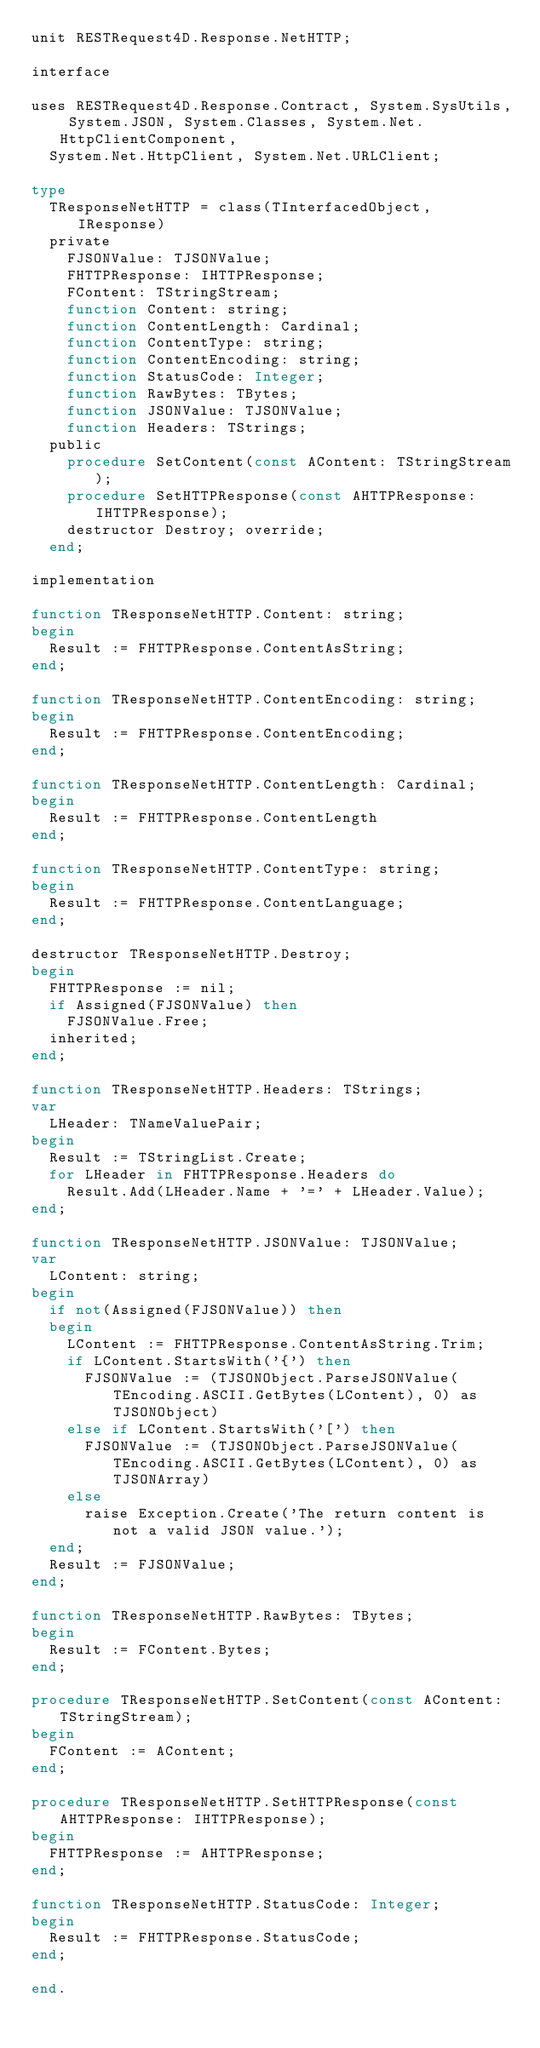Convert code to text. <code><loc_0><loc_0><loc_500><loc_500><_Pascal_>unit RESTRequest4D.Response.NetHTTP;

interface

uses RESTRequest4D.Response.Contract, System.SysUtils, System.JSON, System.Classes, System.Net.HttpClientComponent,
  System.Net.HttpClient, System.Net.URLClient;

type
  TResponseNetHTTP = class(TInterfacedObject, IResponse)
  private
    FJSONValue: TJSONValue;
    FHTTPResponse: IHTTPResponse;
    FContent: TStringStream;
    function Content: string;
    function ContentLength: Cardinal;
    function ContentType: string;
    function ContentEncoding: string;
    function StatusCode: Integer;
    function RawBytes: TBytes;
    function JSONValue: TJSONValue;
    function Headers: TStrings;
  public
    procedure SetContent(const AContent: TStringStream);
    procedure SetHTTPResponse(const AHTTPResponse: IHTTPResponse);
    destructor Destroy; override;
  end;

implementation

function TResponseNetHTTP.Content: string;
begin
  Result := FHTTPResponse.ContentAsString;
end;

function TResponseNetHTTP.ContentEncoding: string;
begin
  Result := FHTTPResponse.ContentEncoding;
end;

function TResponseNetHTTP.ContentLength: Cardinal;
begin
  Result := FHTTPResponse.ContentLength
end;

function TResponseNetHTTP.ContentType: string;
begin
  Result := FHTTPResponse.ContentLanguage;
end;

destructor TResponseNetHTTP.Destroy;
begin
  FHTTPResponse := nil;
  if Assigned(FJSONValue) then
    FJSONValue.Free;
  inherited;
end;

function TResponseNetHTTP.Headers: TStrings;
var
  LHeader: TNameValuePair;
begin
  Result := TStringList.Create;
  for LHeader in FHTTPResponse.Headers do
    Result.Add(LHeader.Name + '=' + LHeader.Value);
end;

function TResponseNetHTTP.JSONValue: TJSONValue;
var
  LContent: string;
begin
  if not(Assigned(FJSONValue)) then
  begin
    LContent := FHTTPResponse.ContentAsString.Trim;
    if LContent.StartsWith('{') then
      FJSONValue := (TJSONObject.ParseJSONValue(TEncoding.ASCII.GetBytes(LContent), 0) as TJSONObject)
    else if LContent.StartsWith('[') then
      FJSONValue := (TJSONObject.ParseJSONValue(TEncoding.ASCII.GetBytes(LContent), 0) as TJSONArray)
    else
      raise Exception.Create('The return content is not a valid JSON value.');
  end;
  Result := FJSONValue;
end;

function TResponseNetHTTP.RawBytes: TBytes;
begin
  Result := FContent.Bytes;
end;

procedure TResponseNetHTTP.SetContent(const AContent: TStringStream);
begin
  FContent := AContent;
end;

procedure TResponseNetHTTP.SetHTTPResponse(const AHTTPResponse: IHTTPResponse);
begin
  FHTTPResponse := AHTTPResponse;
end;

function TResponseNetHTTP.StatusCode: Integer;
begin
  Result := FHTTPResponse.StatusCode;
end;

end.
</code> 